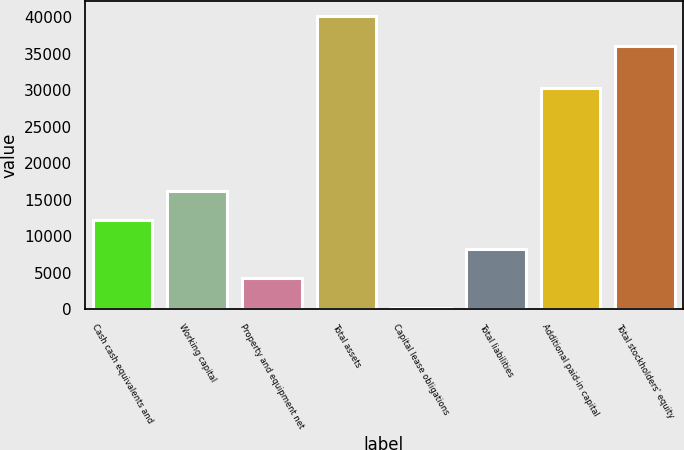Convert chart. <chart><loc_0><loc_0><loc_500><loc_500><bar_chart><fcel>Cash cash equivalents and<fcel>Working capital<fcel>Property and equipment net<fcel>Total assets<fcel>Capital lease obligations<fcel>Total liabilities<fcel>Additional paid-in capital<fcel>Total stockholders' equity<nl><fcel>12218.3<fcel>16213.4<fcel>4228.1<fcel>40184<fcel>233<fcel>8223.2<fcel>30225<fcel>36096<nl></chart> 